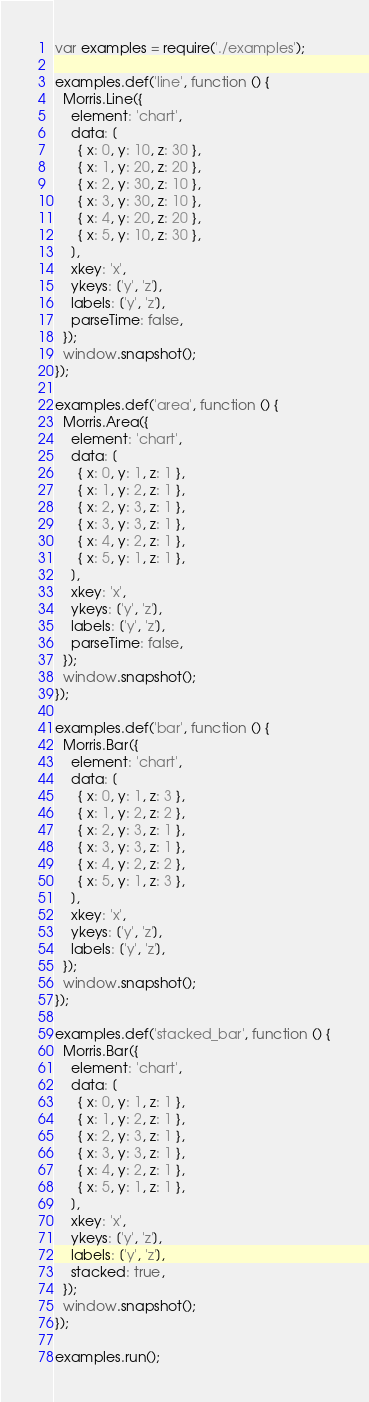Convert code to text. <code><loc_0><loc_0><loc_500><loc_500><_JavaScript_>var examples = require('./examples');

examples.def('line', function () {
  Morris.Line({
    element: 'chart',
    data: [
      { x: 0, y: 10, z: 30 },
      { x: 1, y: 20, z: 20 },
      { x: 2, y: 30, z: 10 },
      { x: 3, y: 30, z: 10 },
      { x: 4, y: 20, z: 20 },
      { x: 5, y: 10, z: 30 },
    ],
    xkey: 'x',
    ykeys: ['y', 'z'],
    labels: ['y', 'z'],
    parseTime: false,
  });
  window.snapshot();
});

examples.def('area', function () {
  Morris.Area({
    element: 'chart',
    data: [
      { x: 0, y: 1, z: 1 },
      { x: 1, y: 2, z: 1 },
      { x: 2, y: 3, z: 1 },
      { x: 3, y: 3, z: 1 },
      { x: 4, y: 2, z: 1 },
      { x: 5, y: 1, z: 1 },
    ],
    xkey: 'x',
    ykeys: ['y', 'z'],
    labels: ['y', 'z'],
    parseTime: false,
  });
  window.snapshot();
});

examples.def('bar', function () {
  Morris.Bar({
    element: 'chart',
    data: [
      { x: 0, y: 1, z: 3 },
      { x: 1, y: 2, z: 2 },
      { x: 2, y: 3, z: 1 },
      { x: 3, y: 3, z: 1 },
      { x: 4, y: 2, z: 2 },
      { x: 5, y: 1, z: 3 },
    ],
    xkey: 'x',
    ykeys: ['y', 'z'],
    labels: ['y', 'z'],
  });
  window.snapshot();
});

examples.def('stacked_bar', function () {
  Morris.Bar({
    element: 'chart',
    data: [
      { x: 0, y: 1, z: 1 },
      { x: 1, y: 2, z: 1 },
      { x: 2, y: 3, z: 1 },
      { x: 3, y: 3, z: 1 },
      { x: 4, y: 2, z: 1 },
      { x: 5, y: 1, z: 1 },
    ],
    xkey: 'x',
    ykeys: ['y', 'z'],
    labels: ['y', 'z'],
    stacked: true,
  });
  window.snapshot();
});

examples.run();
</code> 